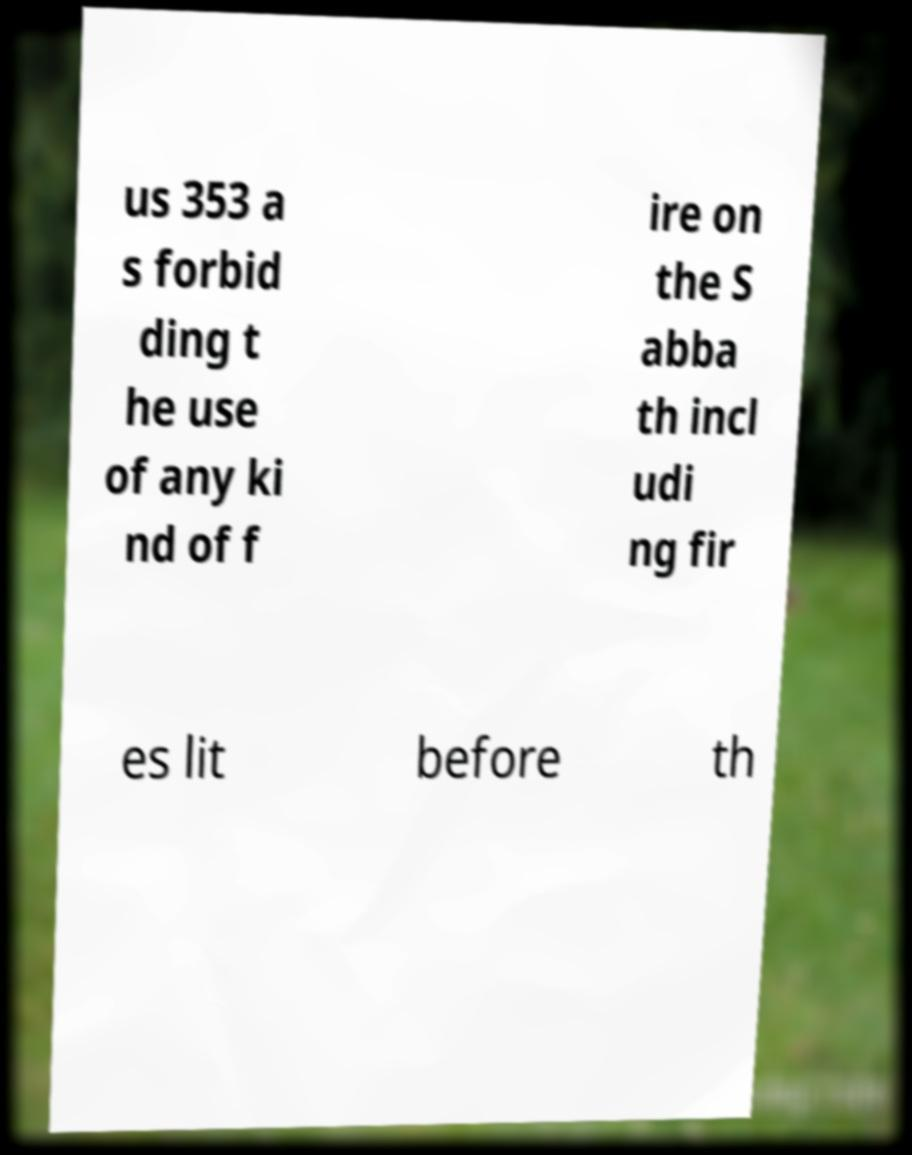I need the written content from this picture converted into text. Can you do that? us 353 a s forbid ding t he use of any ki nd of f ire on the S abba th incl udi ng fir es lit before th 